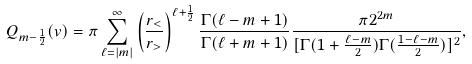<formula> <loc_0><loc_0><loc_500><loc_500>Q _ { m - \frac { 1 } { 2 } } ( v ) = \pi \sum _ { \ell = | m | } ^ { \infty } \left ( \frac { r _ { < } } { r _ { > } } \right ) ^ { \ell + \frac { 1 } { 2 } } \frac { \Gamma ( \ell - m + 1 ) } { \Gamma ( \ell + m + 1 ) } \frac { \pi 2 ^ { 2 m } } { [ \Gamma ( 1 + \frac { \ell - m } { 2 } ) \Gamma ( \frac { 1 - \ell - m } { 2 } ) ] ^ { 2 } } ,</formula> 